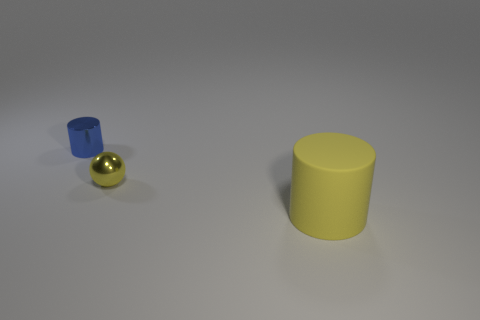There is a tiny thing on the right side of the thing left of the small thing in front of the blue shiny object; what is it made of? The tiny object appears to be a small, golden sphere. Given the realistic rendering and visual clues, it could be interpreted as being made of a polished metal, perhaps brass or gold, exhibiting a reflective surface that casts a subtle glow on the surface beneath it. 